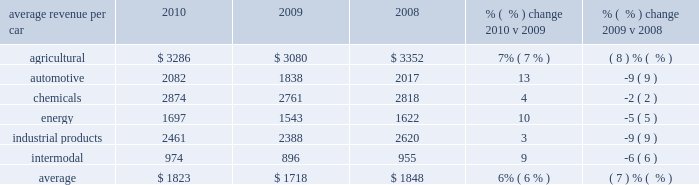Average revenue per car 2010 2009 2008 % (  % ) change 2010 v 2009 % (  % ) change 2009 v 2008 .
Agricultural products 2013 higher volume , fuel surcharges , and price improvements increased agricultural freight revenue in 2010 versus 2009 .
Increased shipments from the midwest to export ports in the pacific northwest combined with heightened demand in mexico drove higher corn and feed grain shipments in 2010 .
Increased corn and feed grain shipments into ethanol plants in california and idaho and continued growth in ethanol shipments also contributed to this increase .
In 2009 , some ethanol plants temporarily ceased operations due to lower ethanol margins , which contributed to the favorable year-over-year comparison .
In addition , strong export demand for u.s .
Wheat via the gulf ports increased shipments of wheat and food grains compared to 2009 .
Declines in domestic wheat and food shipments partially offset the growth in export shipments .
New business in feed and animal protein shipments also increased agricultural shipments in 2010 compared to 2009 .
Lower volume and fuel surcharges decreased agricultural freight revenue in 2009 versus 2008 .
Price improvements partially offset these declines .
Lower demand in both export and domestic markets led to fewer shipments of corn and feed grains , down 11% ( 11 % ) in 2009 compared to 2008 .
Weaker worldwide demand also reduced export shipments of wheat and food grains in 2009 versus 2008 .
Automotive 2013 37% ( 37 % ) and 24% ( 24 % ) increases in shipments of finished vehicles and automotive parts in 2010 , respectively , combined with core pricing gains and fuel surcharges , improved automotive freight revenue from relatively weak 2009 levels .
Economic conditions in 2009 led to poor auto sales and reduced vehicle production , which in turn reduced shipments of finished vehicles and parts during the declines in shipments of finished vehicles and auto parts and lower fuel surcharges reduced freight revenue in 2009 compared to 2008 .
Vehicle shipments were down 35% ( 35 % ) and parts were down 24% ( 24 % ) .
Core pricing gains partially offset these declines .
These volume declines resulted from economic conditions that reduced sales and vehicle production .
In addition , two major domestic automotive manufacturers declared bankruptcy in the second quarter of 2009 , affecting production levels .
Although the federal car allowance rebate system ( the 201ccash for clunkers 201d program ) helped stimulate vehicle sales and shipments in the third quarter of 2009 , production cuts and soft demand throughout the year more than offset the program 2019s benefits .
2010 agricultural revenue 2010 automotive revenue .
In 2010 what was the average revenue per car for agriculture products compared to automotive? 
Computations: (3286 / 2082)
Answer: 1.57829. 